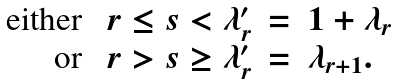Convert formula to latex. <formula><loc_0><loc_0><loc_500><loc_500>\begin{array} { r l } \text {either} \ & r \leq s < \lambda ^ { \prime } _ { r } \, = \, 1 + \lambda _ { r } \\ \text {or} \ & r > s \geq \lambda ^ { \prime } _ { r } \, = \, \lambda _ { r + 1 } . \end{array}</formula> 